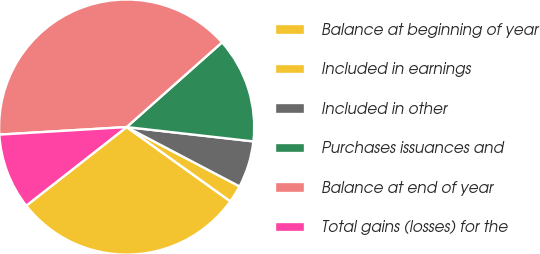Convert chart to OTSL. <chart><loc_0><loc_0><loc_500><loc_500><pie_chart><fcel>Balance at beginning of year<fcel>Included in earnings<fcel>Included in other<fcel>Purchases issuances and<fcel>Balance at end of year<fcel>Total gains (losses) for the<nl><fcel>29.54%<fcel>2.19%<fcel>5.91%<fcel>13.35%<fcel>39.39%<fcel>9.63%<nl></chart> 